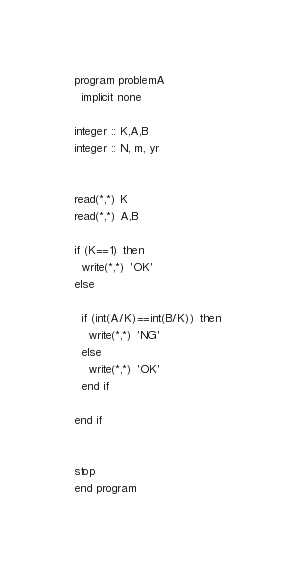<code> <loc_0><loc_0><loc_500><loc_500><_FORTRAN_>program problemA
  implicit none

integer :: K,A,B
integer :: N, m, yr


read(*,*) K
read(*,*) A,B

if (K==1) then
  write(*,*) 'OK'
else

  if (int(A/K)==int(B/K)) then
    write(*,*) 'NG'
  else
    write(*,*) 'OK'
  end if

end if 


stop
end program
</code> 